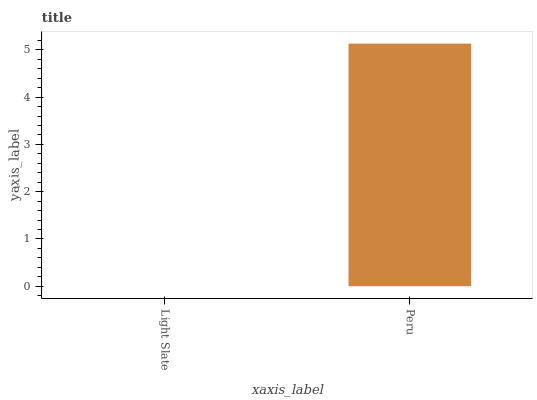Is Light Slate the minimum?
Answer yes or no. Yes. Is Peru the maximum?
Answer yes or no. Yes. Is Peru the minimum?
Answer yes or no. No. Is Peru greater than Light Slate?
Answer yes or no. Yes. Is Light Slate less than Peru?
Answer yes or no. Yes. Is Light Slate greater than Peru?
Answer yes or no. No. Is Peru less than Light Slate?
Answer yes or no. No. Is Peru the high median?
Answer yes or no. Yes. Is Light Slate the low median?
Answer yes or no. Yes. Is Light Slate the high median?
Answer yes or no. No. Is Peru the low median?
Answer yes or no. No. 